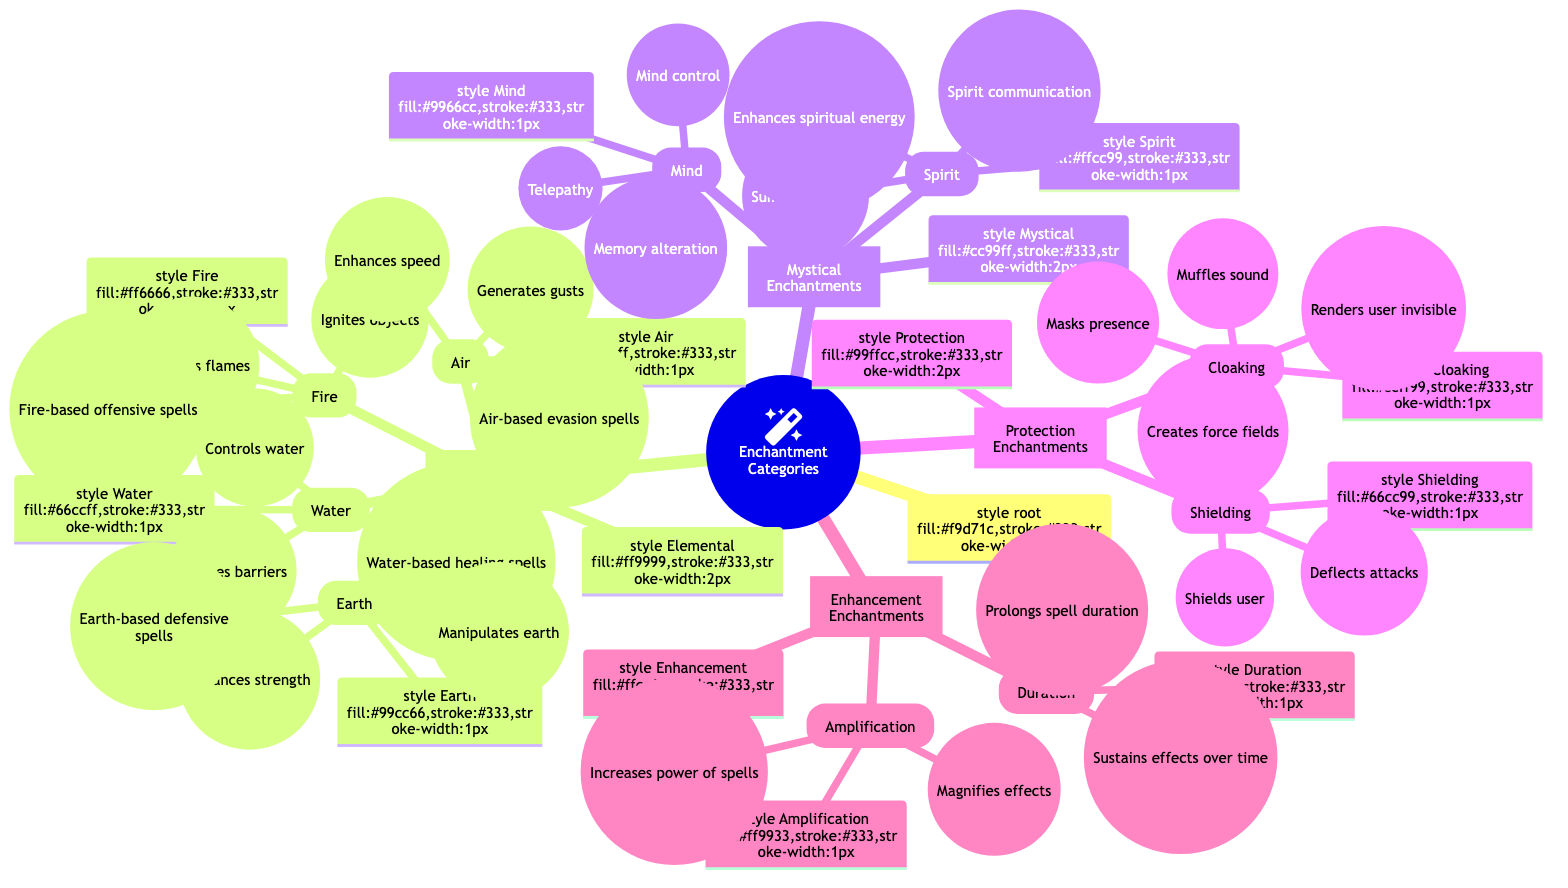What are the two main categories of enchantments? The diagram shows multiple categories of enchantments, but the two main categories are identified: "Elemental Enchantments" and "Mystical Enchantments". These are prominently labeled at the highest level of the diagram.
Answer: Elemental Enchantments, Mystical Enchantments How many types are listed under Elemental Enchantments? The diagram indicates that there are four specific types under the category of "Elemental Enchantments": Fire, Water, Earth, and Air. By counting these, we can confirm the total.
Answer: 4 What effect does the Earth type enchantment provide? Looking at the "Earth" type under "Elemental Enchantments", it specifies that it "Manipulates earth", "Enhances strength", and "Earth-based defensive spells". Thus, the effect primarily involves manipulation and defense.
Answer: Manipulates earth What properties are associated with Cloaking enchantments? The "Cloaking" enchantment listed under "Protection Enchantments" includes properties: "Requires stealth" and "energy-efficient". This indicates how it operates and its energy demands.
Answer: Requires stealth, energy-efficient Which category includes enchantments that enhance existing abilities? The diagram categorizes "Enhancement Enchantments" specifically for enchantments that enhance current abilities or properties. This is visibly distinct from other categories in the diagram.
Answer: Enhancement Enchantments What are the effects of the Mind enchantment? Under the "Mind" type in "Mystical Enchantments", the effects are detailed as "Telepathy", "Mind control", and "Memory alteration". These directly list the capabilities granted by this enchantment type.
Answer: Telepathy, Mind control, Memory alteration How many different protection types are there in the Diagram? The diagram identifies two types under "Protection Enchantments": "Shielding" and "Cloaking". By counting these two, we can determine the total protection types.
Answer: 2 What is the required material for Fire enchantments? From the "Fire" type enchantment described under "Elemental Enchantments", it is stated that it "requires insulation materials" due to its high energy output. This is a key property of fire-based enchantments.
Answer: Insulation materials What category includes the Spirit type enchantment? The "Spirit" type enchantment is found under "Mystical Enchantments". This categorization indicates its nature and the kind of magical forces it taps into.
Answer: Mystical Enchantments 